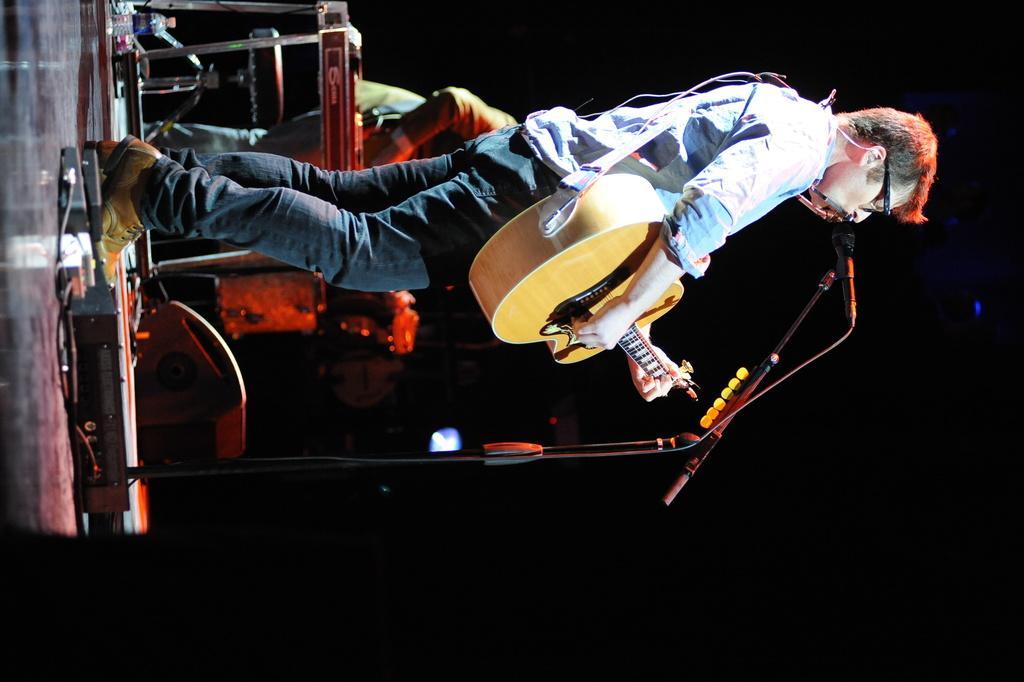In one or two sentences, can you explain what this image depicts? In the middle there is a man he wear shirt ,trouser and shoes, he is playing guitar. In the back ground there is a person ,keyboard and some musical instruments. In the middle there is a mic and mic stand. 